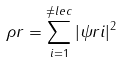<formula> <loc_0><loc_0><loc_500><loc_500>\rho r = \sum _ { i = 1 } ^ { \ne l e c } | \psi r i | ^ { 2 }</formula> 